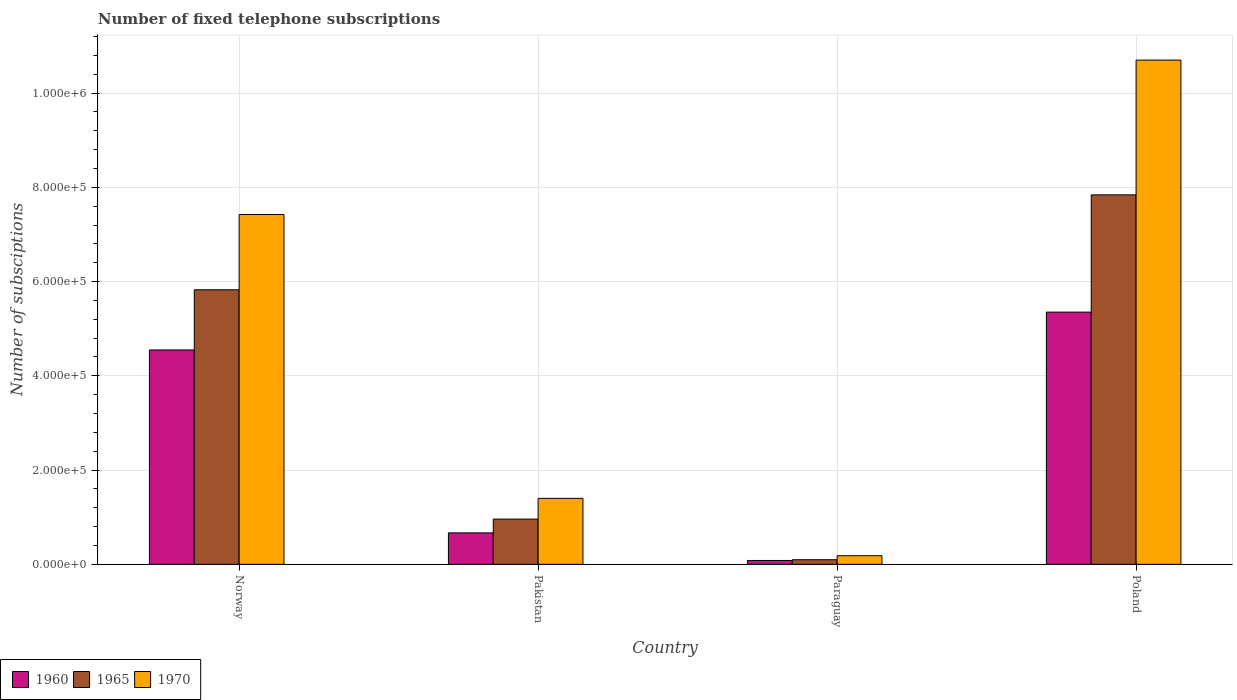How many different coloured bars are there?
Give a very brief answer. 3. How many groups of bars are there?
Give a very brief answer. 4. Are the number of bars on each tick of the X-axis equal?
Offer a terse response. Yes. How many bars are there on the 3rd tick from the left?
Offer a very short reply. 3. How many bars are there on the 1st tick from the right?
Make the answer very short. 3. What is the label of the 3rd group of bars from the left?
Keep it short and to the point. Paraguay. In how many cases, is the number of bars for a given country not equal to the number of legend labels?
Your response must be concise. 0. What is the number of fixed telephone subscriptions in 1970 in Norway?
Your answer should be compact. 7.42e+05. Across all countries, what is the maximum number of fixed telephone subscriptions in 1960?
Ensure brevity in your answer.  5.35e+05. Across all countries, what is the minimum number of fixed telephone subscriptions in 1960?
Your answer should be very brief. 8189. In which country was the number of fixed telephone subscriptions in 1965 maximum?
Provide a succinct answer. Poland. In which country was the number of fixed telephone subscriptions in 1970 minimum?
Provide a short and direct response. Paraguay. What is the total number of fixed telephone subscriptions in 1965 in the graph?
Provide a short and direct response. 1.47e+06. What is the difference between the number of fixed telephone subscriptions in 1960 in Norway and that in Paraguay?
Offer a very short reply. 4.47e+05. What is the difference between the number of fixed telephone subscriptions in 1970 in Paraguay and the number of fixed telephone subscriptions in 1960 in Poland?
Provide a succinct answer. -5.17e+05. What is the average number of fixed telephone subscriptions in 1970 per country?
Ensure brevity in your answer.  4.93e+05. What is the difference between the number of fixed telephone subscriptions of/in 1965 and number of fixed telephone subscriptions of/in 1960 in Paraguay?
Offer a terse response. 1601. In how many countries, is the number of fixed telephone subscriptions in 1965 greater than 1040000?
Keep it short and to the point. 0. What is the ratio of the number of fixed telephone subscriptions in 1970 in Paraguay to that in Poland?
Your answer should be compact. 0.02. Is the number of fixed telephone subscriptions in 1965 in Norway less than that in Paraguay?
Offer a terse response. No. What is the difference between the highest and the second highest number of fixed telephone subscriptions in 1965?
Give a very brief answer. 6.88e+05. What is the difference between the highest and the lowest number of fixed telephone subscriptions in 1970?
Your answer should be compact. 1.05e+06. In how many countries, is the number of fixed telephone subscriptions in 1965 greater than the average number of fixed telephone subscriptions in 1965 taken over all countries?
Offer a very short reply. 2. What does the 2nd bar from the left in Paraguay represents?
Your answer should be compact. 1965. What is the difference between two consecutive major ticks on the Y-axis?
Offer a very short reply. 2.00e+05. Does the graph contain any zero values?
Provide a short and direct response. No. Does the graph contain grids?
Keep it short and to the point. Yes. Where does the legend appear in the graph?
Your answer should be very brief. Bottom left. How many legend labels are there?
Give a very brief answer. 3. What is the title of the graph?
Your answer should be very brief. Number of fixed telephone subscriptions. What is the label or title of the Y-axis?
Your answer should be compact. Number of subsciptions. What is the Number of subsciptions in 1960 in Norway?
Your answer should be compact. 4.55e+05. What is the Number of subsciptions of 1965 in Norway?
Keep it short and to the point. 5.83e+05. What is the Number of subsciptions of 1970 in Norway?
Ensure brevity in your answer.  7.42e+05. What is the Number of subsciptions of 1960 in Pakistan?
Provide a short and direct response. 6.68e+04. What is the Number of subsciptions in 1965 in Pakistan?
Ensure brevity in your answer.  9.60e+04. What is the Number of subsciptions of 1970 in Pakistan?
Your response must be concise. 1.40e+05. What is the Number of subsciptions of 1960 in Paraguay?
Your answer should be very brief. 8189. What is the Number of subsciptions in 1965 in Paraguay?
Make the answer very short. 9790. What is the Number of subsciptions in 1970 in Paraguay?
Your response must be concise. 1.83e+04. What is the Number of subsciptions in 1960 in Poland?
Offer a very short reply. 5.35e+05. What is the Number of subsciptions of 1965 in Poland?
Provide a short and direct response. 7.84e+05. What is the Number of subsciptions of 1970 in Poland?
Your answer should be compact. 1.07e+06. Across all countries, what is the maximum Number of subsciptions in 1960?
Make the answer very short. 5.35e+05. Across all countries, what is the maximum Number of subsciptions in 1965?
Offer a terse response. 7.84e+05. Across all countries, what is the maximum Number of subsciptions in 1970?
Your answer should be very brief. 1.07e+06. Across all countries, what is the minimum Number of subsciptions of 1960?
Make the answer very short. 8189. Across all countries, what is the minimum Number of subsciptions of 1965?
Keep it short and to the point. 9790. Across all countries, what is the minimum Number of subsciptions of 1970?
Provide a short and direct response. 1.83e+04. What is the total Number of subsciptions of 1960 in the graph?
Your answer should be compact. 1.07e+06. What is the total Number of subsciptions in 1965 in the graph?
Your answer should be compact. 1.47e+06. What is the total Number of subsciptions in 1970 in the graph?
Offer a very short reply. 1.97e+06. What is the difference between the Number of subsciptions in 1960 in Norway and that in Pakistan?
Offer a terse response. 3.88e+05. What is the difference between the Number of subsciptions of 1965 in Norway and that in Pakistan?
Offer a terse response. 4.87e+05. What is the difference between the Number of subsciptions of 1970 in Norway and that in Pakistan?
Offer a very short reply. 6.02e+05. What is the difference between the Number of subsciptions of 1960 in Norway and that in Paraguay?
Provide a short and direct response. 4.47e+05. What is the difference between the Number of subsciptions in 1965 in Norway and that in Paraguay?
Provide a short and direct response. 5.73e+05. What is the difference between the Number of subsciptions in 1970 in Norway and that in Paraguay?
Keep it short and to the point. 7.24e+05. What is the difference between the Number of subsciptions of 1960 in Norway and that in Poland?
Provide a short and direct response. -8.03e+04. What is the difference between the Number of subsciptions of 1965 in Norway and that in Poland?
Your response must be concise. -2.01e+05. What is the difference between the Number of subsciptions in 1970 in Norway and that in Poland?
Provide a short and direct response. -3.28e+05. What is the difference between the Number of subsciptions of 1960 in Pakistan and that in Paraguay?
Provide a succinct answer. 5.86e+04. What is the difference between the Number of subsciptions of 1965 in Pakistan and that in Paraguay?
Keep it short and to the point. 8.62e+04. What is the difference between the Number of subsciptions in 1970 in Pakistan and that in Paraguay?
Provide a succinct answer. 1.22e+05. What is the difference between the Number of subsciptions in 1960 in Pakistan and that in Poland?
Your answer should be compact. -4.68e+05. What is the difference between the Number of subsciptions of 1965 in Pakistan and that in Poland?
Your response must be concise. -6.88e+05. What is the difference between the Number of subsciptions in 1970 in Pakistan and that in Poland?
Keep it short and to the point. -9.30e+05. What is the difference between the Number of subsciptions in 1960 in Paraguay and that in Poland?
Ensure brevity in your answer.  -5.27e+05. What is the difference between the Number of subsciptions of 1965 in Paraguay and that in Poland?
Your answer should be compact. -7.74e+05. What is the difference between the Number of subsciptions in 1970 in Paraguay and that in Poland?
Give a very brief answer. -1.05e+06. What is the difference between the Number of subsciptions of 1960 in Norway and the Number of subsciptions of 1965 in Pakistan?
Offer a very short reply. 3.59e+05. What is the difference between the Number of subsciptions in 1960 in Norway and the Number of subsciptions in 1970 in Pakistan?
Offer a very short reply. 3.15e+05. What is the difference between the Number of subsciptions of 1965 in Norway and the Number of subsciptions of 1970 in Pakistan?
Your answer should be very brief. 4.43e+05. What is the difference between the Number of subsciptions of 1960 in Norway and the Number of subsciptions of 1965 in Paraguay?
Your answer should be compact. 4.45e+05. What is the difference between the Number of subsciptions of 1960 in Norway and the Number of subsciptions of 1970 in Paraguay?
Offer a terse response. 4.37e+05. What is the difference between the Number of subsciptions of 1965 in Norway and the Number of subsciptions of 1970 in Paraguay?
Your answer should be compact. 5.64e+05. What is the difference between the Number of subsciptions of 1960 in Norway and the Number of subsciptions of 1965 in Poland?
Keep it short and to the point. -3.29e+05. What is the difference between the Number of subsciptions in 1960 in Norway and the Number of subsciptions in 1970 in Poland?
Provide a succinct answer. -6.15e+05. What is the difference between the Number of subsciptions in 1965 in Norway and the Number of subsciptions in 1970 in Poland?
Make the answer very short. -4.87e+05. What is the difference between the Number of subsciptions of 1960 in Pakistan and the Number of subsciptions of 1965 in Paraguay?
Give a very brief answer. 5.70e+04. What is the difference between the Number of subsciptions in 1960 in Pakistan and the Number of subsciptions in 1970 in Paraguay?
Provide a short and direct response. 4.85e+04. What is the difference between the Number of subsciptions in 1965 in Pakistan and the Number of subsciptions in 1970 in Paraguay?
Make the answer very short. 7.77e+04. What is the difference between the Number of subsciptions of 1960 in Pakistan and the Number of subsciptions of 1965 in Poland?
Your response must be concise. -7.17e+05. What is the difference between the Number of subsciptions of 1960 in Pakistan and the Number of subsciptions of 1970 in Poland?
Offer a very short reply. -1.00e+06. What is the difference between the Number of subsciptions of 1965 in Pakistan and the Number of subsciptions of 1970 in Poland?
Offer a terse response. -9.74e+05. What is the difference between the Number of subsciptions in 1960 in Paraguay and the Number of subsciptions in 1965 in Poland?
Ensure brevity in your answer.  -7.76e+05. What is the difference between the Number of subsciptions of 1960 in Paraguay and the Number of subsciptions of 1970 in Poland?
Give a very brief answer. -1.06e+06. What is the difference between the Number of subsciptions of 1965 in Paraguay and the Number of subsciptions of 1970 in Poland?
Make the answer very short. -1.06e+06. What is the average Number of subsciptions in 1960 per country?
Your response must be concise. 2.66e+05. What is the average Number of subsciptions of 1965 per country?
Ensure brevity in your answer.  3.68e+05. What is the average Number of subsciptions of 1970 per country?
Give a very brief answer. 4.93e+05. What is the difference between the Number of subsciptions of 1960 and Number of subsciptions of 1965 in Norway?
Your response must be concise. -1.28e+05. What is the difference between the Number of subsciptions of 1960 and Number of subsciptions of 1970 in Norway?
Make the answer very short. -2.87e+05. What is the difference between the Number of subsciptions in 1965 and Number of subsciptions in 1970 in Norway?
Provide a short and direct response. -1.60e+05. What is the difference between the Number of subsciptions of 1960 and Number of subsciptions of 1965 in Pakistan?
Ensure brevity in your answer.  -2.92e+04. What is the difference between the Number of subsciptions of 1960 and Number of subsciptions of 1970 in Pakistan?
Your answer should be compact. -7.32e+04. What is the difference between the Number of subsciptions in 1965 and Number of subsciptions in 1970 in Pakistan?
Make the answer very short. -4.40e+04. What is the difference between the Number of subsciptions of 1960 and Number of subsciptions of 1965 in Paraguay?
Give a very brief answer. -1601. What is the difference between the Number of subsciptions of 1960 and Number of subsciptions of 1970 in Paraguay?
Provide a short and direct response. -1.01e+04. What is the difference between the Number of subsciptions of 1965 and Number of subsciptions of 1970 in Paraguay?
Keep it short and to the point. -8509. What is the difference between the Number of subsciptions of 1960 and Number of subsciptions of 1965 in Poland?
Provide a succinct answer. -2.49e+05. What is the difference between the Number of subsciptions in 1960 and Number of subsciptions in 1970 in Poland?
Give a very brief answer. -5.35e+05. What is the difference between the Number of subsciptions in 1965 and Number of subsciptions in 1970 in Poland?
Offer a very short reply. -2.86e+05. What is the ratio of the Number of subsciptions in 1960 in Norway to that in Pakistan?
Your answer should be compact. 6.81. What is the ratio of the Number of subsciptions in 1965 in Norway to that in Pakistan?
Give a very brief answer. 6.07. What is the ratio of the Number of subsciptions of 1970 in Norway to that in Pakistan?
Offer a terse response. 5.3. What is the ratio of the Number of subsciptions of 1960 in Norway to that in Paraguay?
Provide a succinct answer. 55.55. What is the ratio of the Number of subsciptions in 1965 in Norway to that in Paraguay?
Make the answer very short. 59.51. What is the ratio of the Number of subsciptions of 1970 in Norway to that in Paraguay?
Keep it short and to the point. 40.57. What is the ratio of the Number of subsciptions in 1965 in Norway to that in Poland?
Give a very brief answer. 0.74. What is the ratio of the Number of subsciptions in 1970 in Norway to that in Poland?
Provide a short and direct response. 0.69. What is the ratio of the Number of subsciptions of 1960 in Pakistan to that in Paraguay?
Make the answer very short. 8.15. What is the ratio of the Number of subsciptions in 1965 in Pakistan to that in Paraguay?
Your response must be concise. 9.81. What is the ratio of the Number of subsciptions of 1970 in Pakistan to that in Paraguay?
Your response must be concise. 7.65. What is the ratio of the Number of subsciptions of 1960 in Pakistan to that in Poland?
Provide a short and direct response. 0.12. What is the ratio of the Number of subsciptions of 1965 in Pakistan to that in Poland?
Your answer should be compact. 0.12. What is the ratio of the Number of subsciptions of 1970 in Pakistan to that in Poland?
Offer a very short reply. 0.13. What is the ratio of the Number of subsciptions of 1960 in Paraguay to that in Poland?
Keep it short and to the point. 0.02. What is the ratio of the Number of subsciptions in 1965 in Paraguay to that in Poland?
Give a very brief answer. 0.01. What is the ratio of the Number of subsciptions of 1970 in Paraguay to that in Poland?
Make the answer very short. 0.02. What is the difference between the highest and the second highest Number of subsciptions of 1960?
Keep it short and to the point. 8.03e+04. What is the difference between the highest and the second highest Number of subsciptions in 1965?
Give a very brief answer. 2.01e+05. What is the difference between the highest and the second highest Number of subsciptions in 1970?
Your response must be concise. 3.28e+05. What is the difference between the highest and the lowest Number of subsciptions of 1960?
Your response must be concise. 5.27e+05. What is the difference between the highest and the lowest Number of subsciptions of 1965?
Make the answer very short. 7.74e+05. What is the difference between the highest and the lowest Number of subsciptions in 1970?
Offer a terse response. 1.05e+06. 